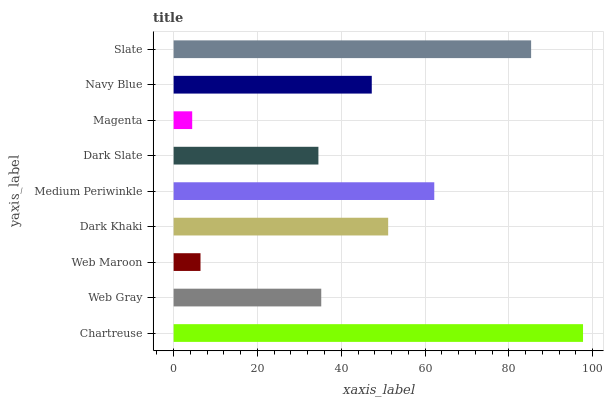Is Magenta the minimum?
Answer yes or no. Yes. Is Chartreuse the maximum?
Answer yes or no. Yes. Is Web Gray the minimum?
Answer yes or no. No. Is Web Gray the maximum?
Answer yes or no. No. Is Chartreuse greater than Web Gray?
Answer yes or no. Yes. Is Web Gray less than Chartreuse?
Answer yes or no. Yes. Is Web Gray greater than Chartreuse?
Answer yes or no. No. Is Chartreuse less than Web Gray?
Answer yes or no. No. Is Navy Blue the high median?
Answer yes or no. Yes. Is Navy Blue the low median?
Answer yes or no. Yes. Is Medium Periwinkle the high median?
Answer yes or no. No. Is Web Gray the low median?
Answer yes or no. No. 